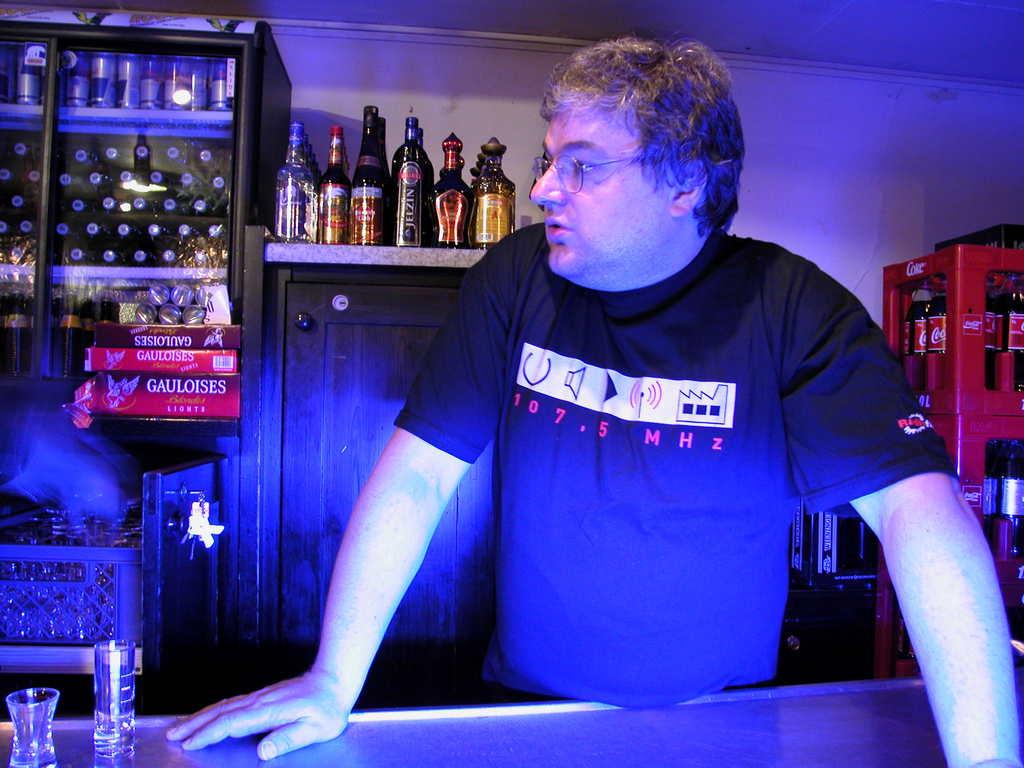Is this man working at a bar?
Make the answer very short. Yes. How many mhz is on the man's shirt?
Your response must be concise. 107.5. 